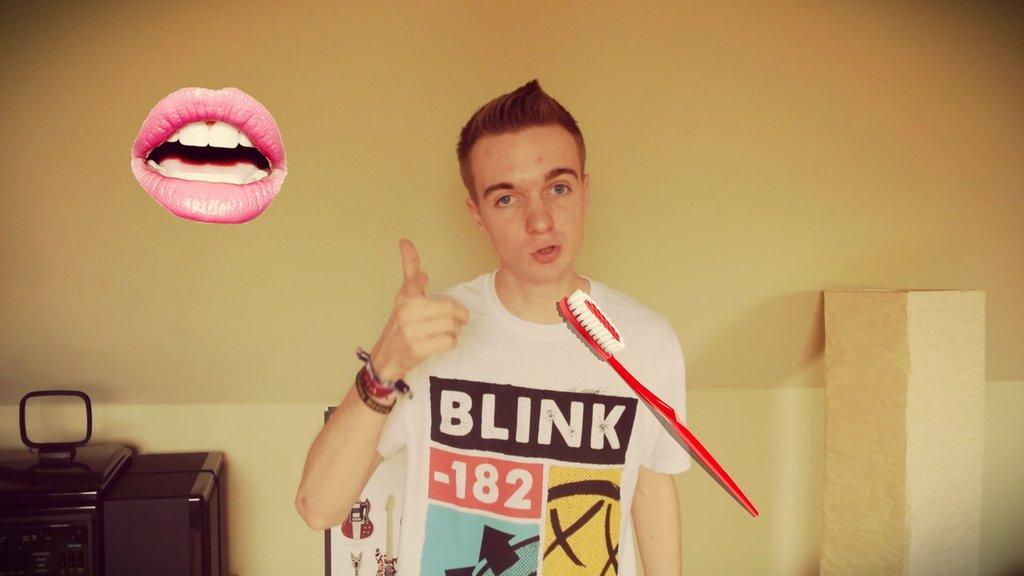What band name is on the t-shirt?
Keep it short and to the point. Blink-182. What numbers are on the shirt?
Your answer should be very brief. 182. 